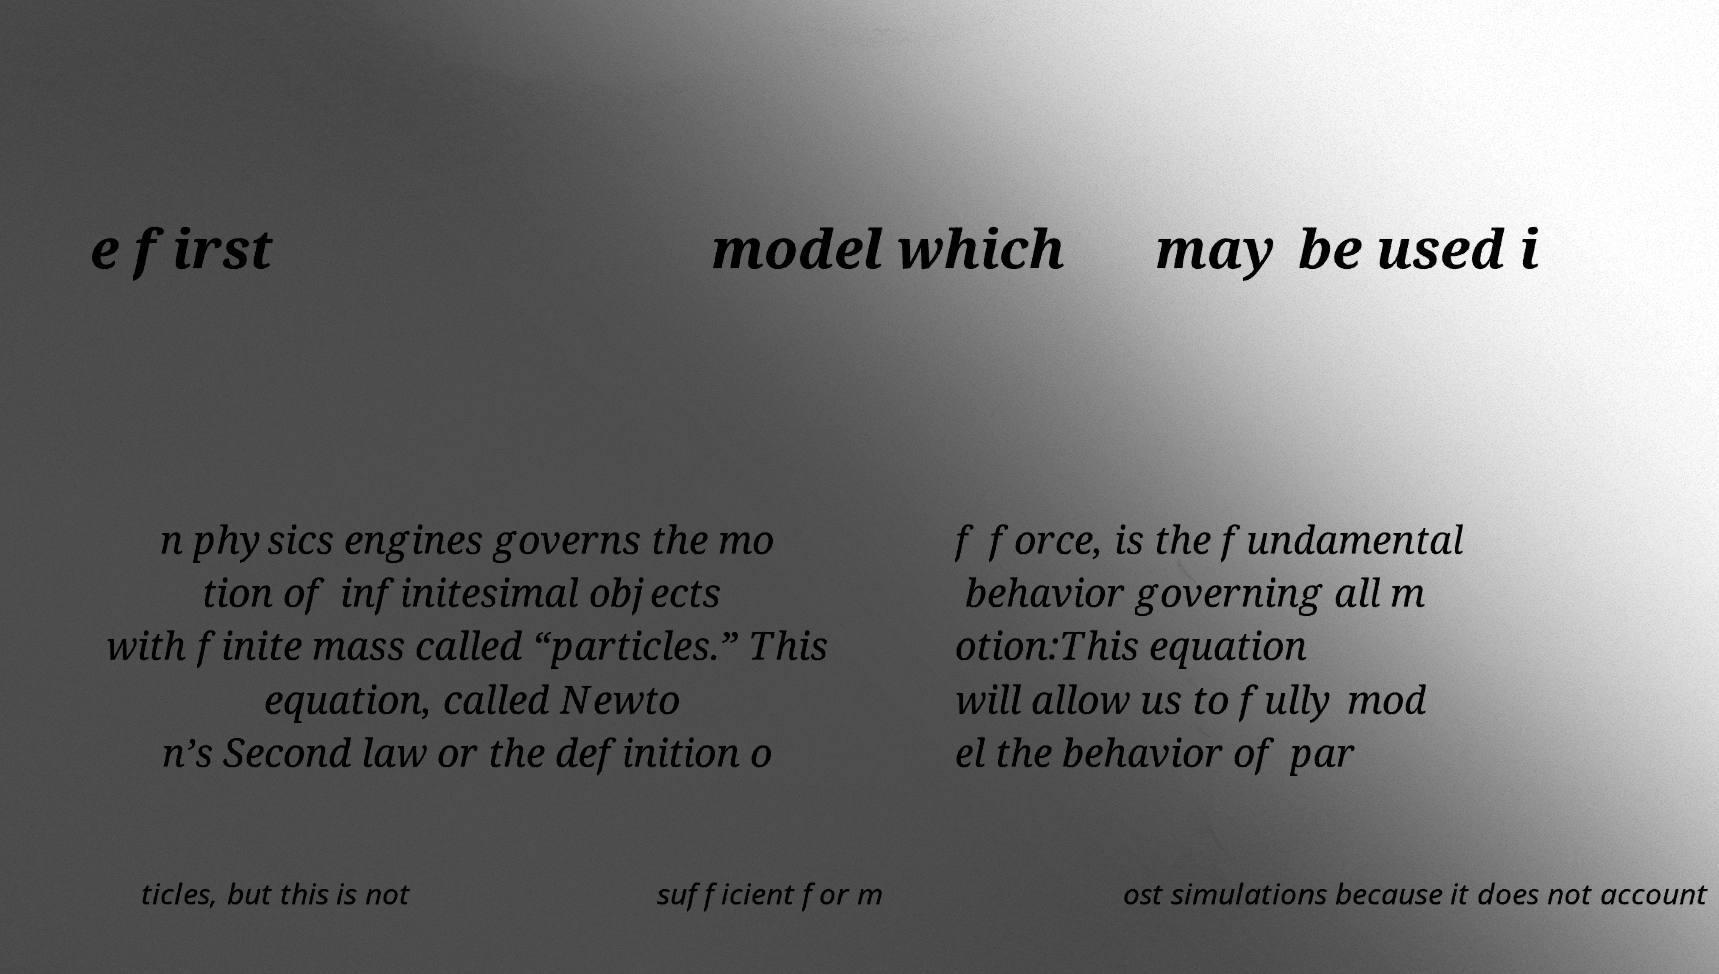Could you extract and type out the text from this image? e first model which may be used i n physics engines governs the mo tion of infinitesimal objects with finite mass called “particles.” This equation, called Newto n’s Second law or the definition o f force, is the fundamental behavior governing all m otion:This equation will allow us to fully mod el the behavior of par ticles, but this is not sufficient for m ost simulations because it does not account 